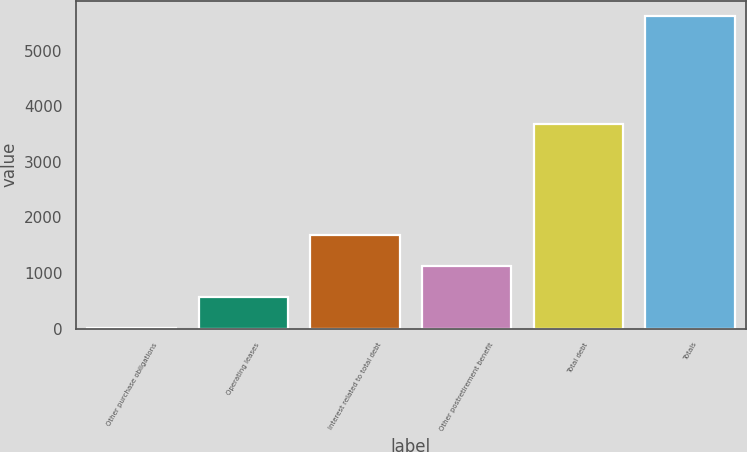Convert chart to OTSL. <chart><loc_0><loc_0><loc_500><loc_500><bar_chart><fcel>Other purchase obligations<fcel>Operating leases<fcel>Interest related to total debt<fcel>Other postretirement benefit<fcel>Total debt<fcel>Totals<nl><fcel>5<fcel>565.8<fcel>1687.4<fcel>1126.6<fcel>3677<fcel>5613<nl></chart> 